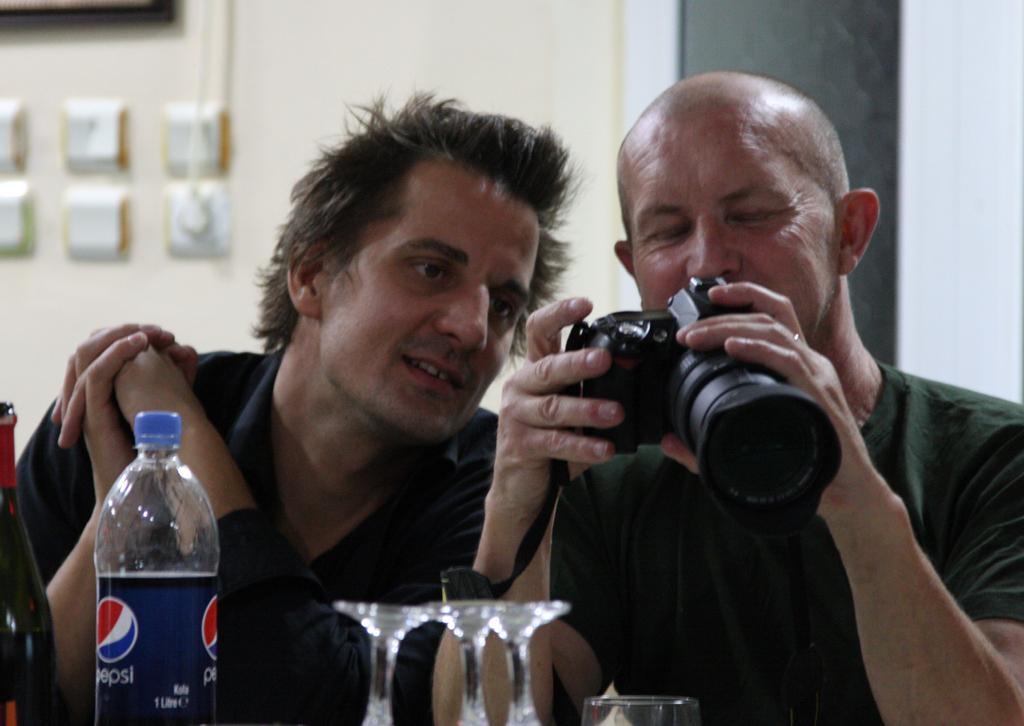Describe this image in one or two sentences. In the picture there are two men sitting together and one is doing some work with the camera there is a table in front of them on the table there are bottles and glasses there is a wall near to them on the wall there are some switches. 